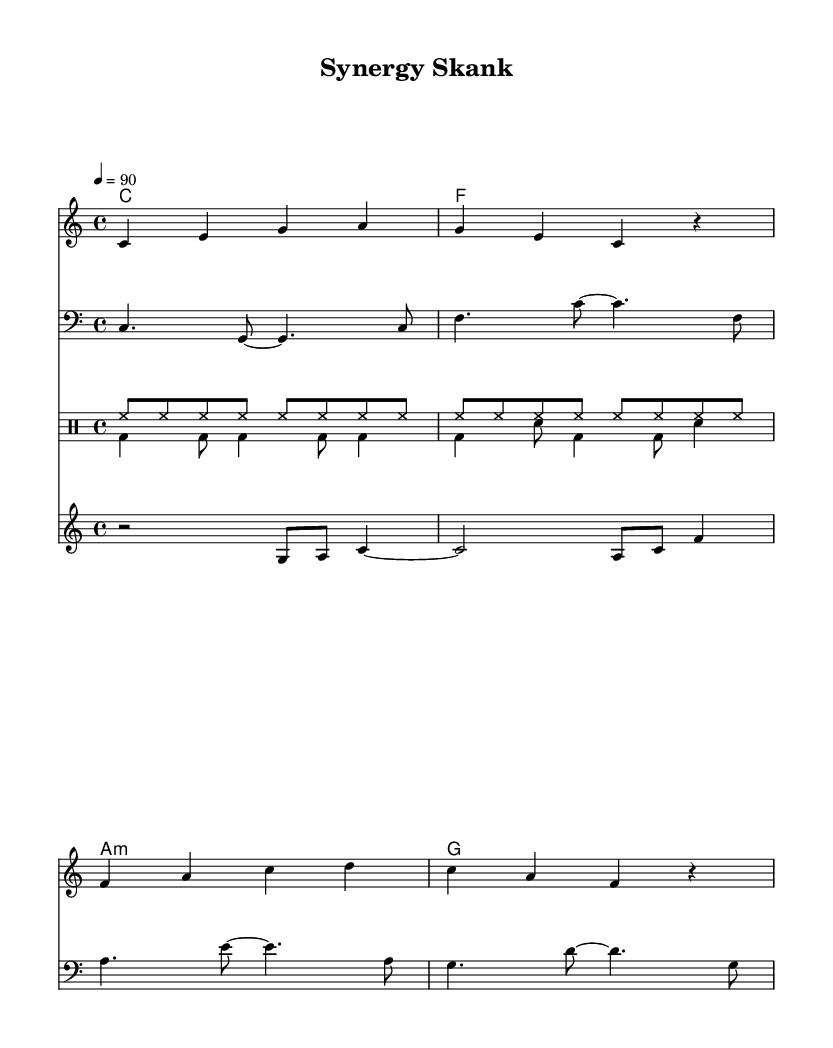What is the key signature of this music? The key signature indicated in the score is C major, which is shown by the absence of any sharps or flats.
Answer: C major What is the time signature of this piece? The time signature at the beginning of the score indicates that there are 4 beats per measure, which is represented as 4/4.
Answer: 4/4 What is the tempo marking? The tempo marking indicates the speed of the piece, which is set at a quarter note equals 90 beats per minute.
Answer: 90 How many sections of drums are present in the score? The score contains two distinct drum sections, identified as drums up and drums down, showing that there are a total of two.
Answer: 2 What is the first lyric line of the melody? The first line of the lyrics corresponds to the first measure of the melody, which is "Sy - ner - gy in the of - fice, yeah."
Answer: Synergy in the office, yeah Which instruments are featured in the score? The score features several instruments: guitar, melody (voice), bass, drum set (with two parts), and brass. Therefore, the total number of instrument types present in the score is five.
Answer: Five 